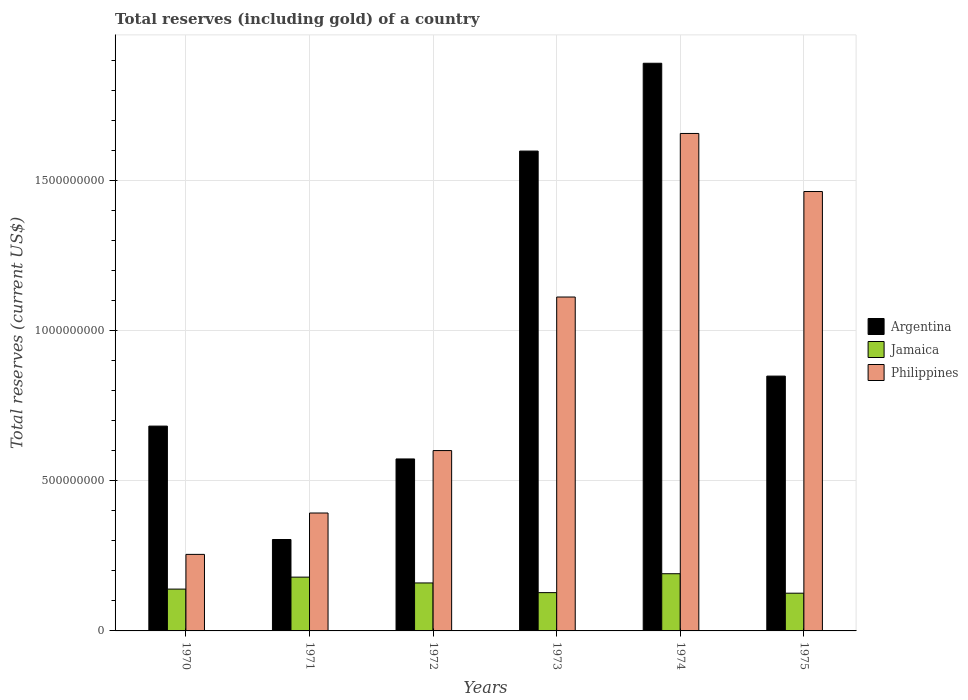Are the number of bars on each tick of the X-axis equal?
Give a very brief answer. Yes. How many bars are there on the 1st tick from the left?
Keep it short and to the point. 3. What is the label of the 6th group of bars from the left?
Your answer should be very brief. 1975. What is the total reserves (including gold) in Philippines in 1970?
Keep it short and to the point. 2.55e+08. Across all years, what is the maximum total reserves (including gold) in Argentina?
Provide a short and direct response. 1.89e+09. Across all years, what is the minimum total reserves (including gold) in Jamaica?
Provide a succinct answer. 1.26e+08. In which year was the total reserves (including gold) in Jamaica maximum?
Give a very brief answer. 1974. In which year was the total reserves (including gold) in Jamaica minimum?
Ensure brevity in your answer.  1975. What is the total total reserves (including gold) in Philippines in the graph?
Ensure brevity in your answer.  5.48e+09. What is the difference between the total reserves (including gold) in Jamaica in 1972 and that in 1974?
Give a very brief answer. -3.07e+07. What is the difference between the total reserves (including gold) in Philippines in 1975 and the total reserves (including gold) in Argentina in 1971?
Provide a succinct answer. 1.16e+09. What is the average total reserves (including gold) in Philippines per year?
Your response must be concise. 9.13e+08. In the year 1974, what is the difference between the total reserves (including gold) in Argentina and total reserves (including gold) in Jamaica?
Offer a terse response. 1.70e+09. In how many years, is the total reserves (including gold) in Philippines greater than 100000000 US$?
Give a very brief answer. 6. What is the ratio of the total reserves (including gold) in Philippines in 1972 to that in 1975?
Make the answer very short. 0.41. Is the difference between the total reserves (including gold) in Argentina in 1972 and 1973 greater than the difference between the total reserves (including gold) in Jamaica in 1972 and 1973?
Provide a short and direct response. No. What is the difference between the highest and the second highest total reserves (including gold) in Philippines?
Give a very brief answer. 1.93e+08. What is the difference between the highest and the lowest total reserves (including gold) in Philippines?
Your answer should be very brief. 1.40e+09. In how many years, is the total reserves (including gold) in Philippines greater than the average total reserves (including gold) in Philippines taken over all years?
Ensure brevity in your answer.  3. Is the sum of the total reserves (including gold) in Philippines in 1972 and 1975 greater than the maximum total reserves (including gold) in Argentina across all years?
Make the answer very short. Yes. What does the 2nd bar from the left in 1970 represents?
Your answer should be compact. Jamaica. What does the 3rd bar from the right in 1970 represents?
Your answer should be compact. Argentina. Is it the case that in every year, the sum of the total reserves (including gold) in Jamaica and total reserves (including gold) in Argentina is greater than the total reserves (including gold) in Philippines?
Provide a succinct answer. No. How many bars are there?
Give a very brief answer. 18. Are all the bars in the graph horizontal?
Give a very brief answer. No. Are the values on the major ticks of Y-axis written in scientific E-notation?
Offer a very short reply. No. Where does the legend appear in the graph?
Keep it short and to the point. Center right. What is the title of the graph?
Give a very brief answer. Total reserves (including gold) of a country. Does "Georgia" appear as one of the legend labels in the graph?
Provide a short and direct response. No. What is the label or title of the Y-axis?
Provide a succinct answer. Total reserves (current US$). What is the Total reserves (current US$) of Argentina in 1970?
Provide a succinct answer. 6.82e+08. What is the Total reserves (current US$) in Jamaica in 1970?
Offer a very short reply. 1.39e+08. What is the Total reserves (current US$) of Philippines in 1970?
Your answer should be compact. 2.55e+08. What is the Total reserves (current US$) of Argentina in 1971?
Your answer should be very brief. 3.04e+08. What is the Total reserves (current US$) of Jamaica in 1971?
Make the answer very short. 1.79e+08. What is the Total reserves (current US$) in Philippines in 1971?
Keep it short and to the point. 3.93e+08. What is the Total reserves (current US$) in Argentina in 1972?
Give a very brief answer. 5.72e+08. What is the Total reserves (current US$) in Jamaica in 1972?
Make the answer very short. 1.60e+08. What is the Total reserves (current US$) of Philippines in 1972?
Provide a succinct answer. 6.00e+08. What is the Total reserves (current US$) in Argentina in 1973?
Provide a succinct answer. 1.60e+09. What is the Total reserves (current US$) in Jamaica in 1973?
Make the answer very short. 1.27e+08. What is the Total reserves (current US$) of Philippines in 1973?
Provide a succinct answer. 1.11e+09. What is the Total reserves (current US$) in Argentina in 1974?
Offer a very short reply. 1.89e+09. What is the Total reserves (current US$) of Jamaica in 1974?
Your response must be concise. 1.90e+08. What is the Total reserves (current US$) of Philippines in 1974?
Ensure brevity in your answer.  1.66e+09. What is the Total reserves (current US$) of Argentina in 1975?
Your response must be concise. 8.48e+08. What is the Total reserves (current US$) in Jamaica in 1975?
Provide a short and direct response. 1.26e+08. What is the Total reserves (current US$) of Philippines in 1975?
Give a very brief answer. 1.46e+09. Across all years, what is the maximum Total reserves (current US$) of Argentina?
Your answer should be very brief. 1.89e+09. Across all years, what is the maximum Total reserves (current US$) of Jamaica?
Make the answer very short. 1.90e+08. Across all years, what is the maximum Total reserves (current US$) in Philippines?
Provide a short and direct response. 1.66e+09. Across all years, what is the minimum Total reserves (current US$) in Argentina?
Offer a terse response. 3.04e+08. Across all years, what is the minimum Total reserves (current US$) of Jamaica?
Your answer should be compact. 1.26e+08. Across all years, what is the minimum Total reserves (current US$) of Philippines?
Your response must be concise. 2.55e+08. What is the total Total reserves (current US$) of Argentina in the graph?
Provide a short and direct response. 5.89e+09. What is the total Total reserves (current US$) in Jamaica in the graph?
Provide a short and direct response. 9.21e+08. What is the total Total reserves (current US$) of Philippines in the graph?
Your response must be concise. 5.48e+09. What is the difference between the Total reserves (current US$) in Argentina in 1970 and that in 1971?
Your answer should be compact. 3.77e+08. What is the difference between the Total reserves (current US$) of Jamaica in 1970 and that in 1971?
Provide a succinct answer. -3.99e+07. What is the difference between the Total reserves (current US$) in Philippines in 1970 and that in 1971?
Your answer should be very brief. -1.38e+08. What is the difference between the Total reserves (current US$) in Argentina in 1970 and that in 1972?
Offer a very short reply. 1.09e+08. What is the difference between the Total reserves (current US$) of Jamaica in 1970 and that in 1972?
Provide a succinct answer. -2.05e+07. What is the difference between the Total reserves (current US$) in Philippines in 1970 and that in 1972?
Offer a terse response. -3.46e+08. What is the difference between the Total reserves (current US$) of Argentina in 1970 and that in 1973?
Your answer should be very brief. -9.15e+08. What is the difference between the Total reserves (current US$) of Jamaica in 1970 and that in 1973?
Make the answer very short. 1.17e+07. What is the difference between the Total reserves (current US$) in Philippines in 1970 and that in 1973?
Offer a terse response. -8.57e+08. What is the difference between the Total reserves (current US$) in Argentina in 1970 and that in 1974?
Provide a succinct answer. -1.21e+09. What is the difference between the Total reserves (current US$) of Jamaica in 1970 and that in 1974?
Ensure brevity in your answer.  -5.12e+07. What is the difference between the Total reserves (current US$) of Philippines in 1970 and that in 1974?
Make the answer very short. -1.40e+09. What is the difference between the Total reserves (current US$) in Argentina in 1970 and that in 1975?
Ensure brevity in your answer.  -1.66e+08. What is the difference between the Total reserves (current US$) of Jamaica in 1970 and that in 1975?
Give a very brief answer. 1.36e+07. What is the difference between the Total reserves (current US$) in Philippines in 1970 and that in 1975?
Offer a very short reply. -1.21e+09. What is the difference between the Total reserves (current US$) of Argentina in 1971 and that in 1972?
Keep it short and to the point. -2.68e+08. What is the difference between the Total reserves (current US$) of Jamaica in 1971 and that in 1972?
Keep it short and to the point. 1.94e+07. What is the difference between the Total reserves (current US$) of Philippines in 1971 and that in 1972?
Give a very brief answer. -2.08e+08. What is the difference between the Total reserves (current US$) of Argentina in 1971 and that in 1973?
Your answer should be very brief. -1.29e+09. What is the difference between the Total reserves (current US$) of Jamaica in 1971 and that in 1973?
Ensure brevity in your answer.  5.16e+07. What is the difference between the Total reserves (current US$) in Philippines in 1971 and that in 1973?
Ensure brevity in your answer.  -7.19e+08. What is the difference between the Total reserves (current US$) in Argentina in 1971 and that in 1974?
Keep it short and to the point. -1.59e+09. What is the difference between the Total reserves (current US$) of Jamaica in 1971 and that in 1974?
Give a very brief answer. -1.13e+07. What is the difference between the Total reserves (current US$) of Philippines in 1971 and that in 1974?
Provide a succinct answer. -1.26e+09. What is the difference between the Total reserves (current US$) of Argentina in 1971 and that in 1975?
Keep it short and to the point. -5.44e+08. What is the difference between the Total reserves (current US$) of Jamaica in 1971 and that in 1975?
Keep it short and to the point. 5.35e+07. What is the difference between the Total reserves (current US$) of Philippines in 1971 and that in 1975?
Keep it short and to the point. -1.07e+09. What is the difference between the Total reserves (current US$) of Argentina in 1972 and that in 1973?
Your answer should be very brief. -1.02e+09. What is the difference between the Total reserves (current US$) of Jamaica in 1972 and that in 1973?
Give a very brief answer. 3.22e+07. What is the difference between the Total reserves (current US$) of Philippines in 1972 and that in 1973?
Your answer should be very brief. -5.11e+08. What is the difference between the Total reserves (current US$) of Argentina in 1972 and that in 1974?
Your answer should be compact. -1.32e+09. What is the difference between the Total reserves (current US$) in Jamaica in 1972 and that in 1974?
Provide a short and direct response. -3.07e+07. What is the difference between the Total reserves (current US$) in Philippines in 1972 and that in 1974?
Your answer should be compact. -1.06e+09. What is the difference between the Total reserves (current US$) in Argentina in 1972 and that in 1975?
Provide a short and direct response. -2.76e+08. What is the difference between the Total reserves (current US$) of Jamaica in 1972 and that in 1975?
Give a very brief answer. 3.41e+07. What is the difference between the Total reserves (current US$) in Philippines in 1972 and that in 1975?
Give a very brief answer. -8.62e+08. What is the difference between the Total reserves (current US$) of Argentina in 1973 and that in 1974?
Your response must be concise. -2.92e+08. What is the difference between the Total reserves (current US$) in Jamaica in 1973 and that in 1974?
Offer a terse response. -6.29e+07. What is the difference between the Total reserves (current US$) of Philippines in 1973 and that in 1974?
Keep it short and to the point. -5.44e+08. What is the difference between the Total reserves (current US$) in Argentina in 1973 and that in 1975?
Your answer should be very brief. 7.49e+08. What is the difference between the Total reserves (current US$) in Jamaica in 1973 and that in 1975?
Make the answer very short. 1.87e+06. What is the difference between the Total reserves (current US$) of Philippines in 1973 and that in 1975?
Provide a short and direct response. -3.51e+08. What is the difference between the Total reserves (current US$) of Argentina in 1974 and that in 1975?
Keep it short and to the point. 1.04e+09. What is the difference between the Total reserves (current US$) in Jamaica in 1974 and that in 1975?
Your response must be concise. 6.48e+07. What is the difference between the Total reserves (current US$) in Philippines in 1974 and that in 1975?
Your answer should be very brief. 1.93e+08. What is the difference between the Total reserves (current US$) of Argentina in 1970 and the Total reserves (current US$) of Jamaica in 1971?
Provide a short and direct response. 5.03e+08. What is the difference between the Total reserves (current US$) of Argentina in 1970 and the Total reserves (current US$) of Philippines in 1971?
Offer a very short reply. 2.89e+08. What is the difference between the Total reserves (current US$) in Jamaica in 1970 and the Total reserves (current US$) in Philippines in 1971?
Keep it short and to the point. -2.53e+08. What is the difference between the Total reserves (current US$) of Argentina in 1970 and the Total reserves (current US$) of Jamaica in 1972?
Ensure brevity in your answer.  5.22e+08. What is the difference between the Total reserves (current US$) of Argentina in 1970 and the Total reserves (current US$) of Philippines in 1972?
Offer a terse response. 8.15e+07. What is the difference between the Total reserves (current US$) in Jamaica in 1970 and the Total reserves (current US$) in Philippines in 1972?
Provide a succinct answer. -4.61e+08. What is the difference between the Total reserves (current US$) of Argentina in 1970 and the Total reserves (current US$) of Jamaica in 1973?
Offer a terse response. 5.54e+08. What is the difference between the Total reserves (current US$) of Argentina in 1970 and the Total reserves (current US$) of Philippines in 1973?
Keep it short and to the point. -4.30e+08. What is the difference between the Total reserves (current US$) of Jamaica in 1970 and the Total reserves (current US$) of Philippines in 1973?
Keep it short and to the point. -9.72e+08. What is the difference between the Total reserves (current US$) in Argentina in 1970 and the Total reserves (current US$) in Jamaica in 1974?
Your answer should be compact. 4.91e+08. What is the difference between the Total reserves (current US$) of Argentina in 1970 and the Total reserves (current US$) of Philippines in 1974?
Your response must be concise. -9.74e+08. What is the difference between the Total reserves (current US$) of Jamaica in 1970 and the Total reserves (current US$) of Philippines in 1974?
Make the answer very short. -1.52e+09. What is the difference between the Total reserves (current US$) of Argentina in 1970 and the Total reserves (current US$) of Jamaica in 1975?
Provide a short and direct response. 5.56e+08. What is the difference between the Total reserves (current US$) in Argentina in 1970 and the Total reserves (current US$) in Philippines in 1975?
Ensure brevity in your answer.  -7.81e+08. What is the difference between the Total reserves (current US$) of Jamaica in 1970 and the Total reserves (current US$) of Philippines in 1975?
Your answer should be very brief. -1.32e+09. What is the difference between the Total reserves (current US$) in Argentina in 1971 and the Total reserves (current US$) in Jamaica in 1972?
Your answer should be compact. 1.45e+08. What is the difference between the Total reserves (current US$) in Argentina in 1971 and the Total reserves (current US$) in Philippines in 1972?
Your response must be concise. -2.96e+08. What is the difference between the Total reserves (current US$) of Jamaica in 1971 and the Total reserves (current US$) of Philippines in 1972?
Your response must be concise. -4.21e+08. What is the difference between the Total reserves (current US$) of Argentina in 1971 and the Total reserves (current US$) of Jamaica in 1973?
Provide a short and direct response. 1.77e+08. What is the difference between the Total reserves (current US$) of Argentina in 1971 and the Total reserves (current US$) of Philippines in 1973?
Provide a succinct answer. -8.07e+08. What is the difference between the Total reserves (current US$) of Jamaica in 1971 and the Total reserves (current US$) of Philippines in 1973?
Offer a terse response. -9.32e+08. What is the difference between the Total reserves (current US$) of Argentina in 1971 and the Total reserves (current US$) of Jamaica in 1974?
Ensure brevity in your answer.  1.14e+08. What is the difference between the Total reserves (current US$) of Argentina in 1971 and the Total reserves (current US$) of Philippines in 1974?
Keep it short and to the point. -1.35e+09. What is the difference between the Total reserves (current US$) of Jamaica in 1971 and the Total reserves (current US$) of Philippines in 1974?
Your answer should be compact. -1.48e+09. What is the difference between the Total reserves (current US$) of Argentina in 1971 and the Total reserves (current US$) of Jamaica in 1975?
Your response must be concise. 1.79e+08. What is the difference between the Total reserves (current US$) in Argentina in 1971 and the Total reserves (current US$) in Philippines in 1975?
Your answer should be very brief. -1.16e+09. What is the difference between the Total reserves (current US$) of Jamaica in 1971 and the Total reserves (current US$) of Philippines in 1975?
Offer a very short reply. -1.28e+09. What is the difference between the Total reserves (current US$) in Argentina in 1972 and the Total reserves (current US$) in Jamaica in 1973?
Offer a very short reply. 4.45e+08. What is the difference between the Total reserves (current US$) of Argentina in 1972 and the Total reserves (current US$) of Philippines in 1973?
Your answer should be very brief. -5.39e+08. What is the difference between the Total reserves (current US$) in Jamaica in 1972 and the Total reserves (current US$) in Philippines in 1973?
Your response must be concise. -9.52e+08. What is the difference between the Total reserves (current US$) in Argentina in 1972 and the Total reserves (current US$) in Jamaica in 1974?
Ensure brevity in your answer.  3.82e+08. What is the difference between the Total reserves (current US$) of Argentina in 1972 and the Total reserves (current US$) of Philippines in 1974?
Keep it short and to the point. -1.08e+09. What is the difference between the Total reserves (current US$) of Jamaica in 1972 and the Total reserves (current US$) of Philippines in 1974?
Offer a very short reply. -1.50e+09. What is the difference between the Total reserves (current US$) in Argentina in 1972 and the Total reserves (current US$) in Jamaica in 1975?
Your answer should be very brief. 4.47e+08. What is the difference between the Total reserves (current US$) of Argentina in 1972 and the Total reserves (current US$) of Philippines in 1975?
Ensure brevity in your answer.  -8.90e+08. What is the difference between the Total reserves (current US$) of Jamaica in 1972 and the Total reserves (current US$) of Philippines in 1975?
Ensure brevity in your answer.  -1.30e+09. What is the difference between the Total reserves (current US$) in Argentina in 1973 and the Total reserves (current US$) in Jamaica in 1974?
Make the answer very short. 1.41e+09. What is the difference between the Total reserves (current US$) in Argentina in 1973 and the Total reserves (current US$) in Philippines in 1974?
Provide a short and direct response. -5.86e+07. What is the difference between the Total reserves (current US$) of Jamaica in 1973 and the Total reserves (current US$) of Philippines in 1974?
Provide a succinct answer. -1.53e+09. What is the difference between the Total reserves (current US$) in Argentina in 1973 and the Total reserves (current US$) in Jamaica in 1975?
Ensure brevity in your answer.  1.47e+09. What is the difference between the Total reserves (current US$) in Argentina in 1973 and the Total reserves (current US$) in Philippines in 1975?
Your response must be concise. 1.35e+08. What is the difference between the Total reserves (current US$) of Jamaica in 1973 and the Total reserves (current US$) of Philippines in 1975?
Your answer should be compact. -1.34e+09. What is the difference between the Total reserves (current US$) of Argentina in 1974 and the Total reserves (current US$) of Jamaica in 1975?
Keep it short and to the point. 1.76e+09. What is the difference between the Total reserves (current US$) of Argentina in 1974 and the Total reserves (current US$) of Philippines in 1975?
Your answer should be compact. 4.27e+08. What is the difference between the Total reserves (current US$) of Jamaica in 1974 and the Total reserves (current US$) of Philippines in 1975?
Your response must be concise. -1.27e+09. What is the average Total reserves (current US$) in Argentina per year?
Offer a terse response. 9.82e+08. What is the average Total reserves (current US$) in Jamaica per year?
Your answer should be very brief. 1.54e+08. What is the average Total reserves (current US$) of Philippines per year?
Provide a succinct answer. 9.13e+08. In the year 1970, what is the difference between the Total reserves (current US$) of Argentina and Total reserves (current US$) of Jamaica?
Offer a very short reply. 5.43e+08. In the year 1970, what is the difference between the Total reserves (current US$) in Argentina and Total reserves (current US$) in Philippines?
Offer a very short reply. 4.27e+08. In the year 1970, what is the difference between the Total reserves (current US$) in Jamaica and Total reserves (current US$) in Philippines?
Make the answer very short. -1.16e+08. In the year 1971, what is the difference between the Total reserves (current US$) in Argentina and Total reserves (current US$) in Jamaica?
Give a very brief answer. 1.25e+08. In the year 1971, what is the difference between the Total reserves (current US$) in Argentina and Total reserves (current US$) in Philippines?
Make the answer very short. -8.82e+07. In the year 1971, what is the difference between the Total reserves (current US$) of Jamaica and Total reserves (current US$) of Philippines?
Your answer should be compact. -2.13e+08. In the year 1972, what is the difference between the Total reserves (current US$) in Argentina and Total reserves (current US$) in Jamaica?
Ensure brevity in your answer.  4.13e+08. In the year 1972, what is the difference between the Total reserves (current US$) in Argentina and Total reserves (current US$) in Philippines?
Give a very brief answer. -2.79e+07. In the year 1972, what is the difference between the Total reserves (current US$) in Jamaica and Total reserves (current US$) in Philippines?
Your answer should be compact. -4.41e+08. In the year 1973, what is the difference between the Total reserves (current US$) in Argentina and Total reserves (current US$) in Jamaica?
Offer a very short reply. 1.47e+09. In the year 1973, what is the difference between the Total reserves (current US$) in Argentina and Total reserves (current US$) in Philippines?
Provide a short and direct response. 4.86e+08. In the year 1973, what is the difference between the Total reserves (current US$) of Jamaica and Total reserves (current US$) of Philippines?
Keep it short and to the point. -9.84e+08. In the year 1974, what is the difference between the Total reserves (current US$) of Argentina and Total reserves (current US$) of Jamaica?
Your answer should be very brief. 1.70e+09. In the year 1974, what is the difference between the Total reserves (current US$) of Argentina and Total reserves (current US$) of Philippines?
Your response must be concise. 2.34e+08. In the year 1974, what is the difference between the Total reserves (current US$) of Jamaica and Total reserves (current US$) of Philippines?
Your response must be concise. -1.47e+09. In the year 1975, what is the difference between the Total reserves (current US$) in Argentina and Total reserves (current US$) in Jamaica?
Offer a terse response. 7.23e+08. In the year 1975, what is the difference between the Total reserves (current US$) in Argentina and Total reserves (current US$) in Philippines?
Your answer should be compact. -6.14e+08. In the year 1975, what is the difference between the Total reserves (current US$) in Jamaica and Total reserves (current US$) in Philippines?
Provide a succinct answer. -1.34e+09. What is the ratio of the Total reserves (current US$) in Argentina in 1970 to that in 1971?
Your response must be concise. 2.24. What is the ratio of the Total reserves (current US$) of Jamaica in 1970 to that in 1971?
Offer a very short reply. 0.78. What is the ratio of the Total reserves (current US$) in Philippines in 1970 to that in 1971?
Provide a short and direct response. 0.65. What is the ratio of the Total reserves (current US$) in Argentina in 1970 to that in 1972?
Provide a short and direct response. 1.19. What is the ratio of the Total reserves (current US$) of Jamaica in 1970 to that in 1972?
Provide a succinct answer. 0.87. What is the ratio of the Total reserves (current US$) in Philippines in 1970 to that in 1972?
Give a very brief answer. 0.42. What is the ratio of the Total reserves (current US$) in Argentina in 1970 to that in 1973?
Your answer should be compact. 0.43. What is the ratio of the Total reserves (current US$) in Jamaica in 1970 to that in 1973?
Give a very brief answer. 1.09. What is the ratio of the Total reserves (current US$) in Philippines in 1970 to that in 1973?
Keep it short and to the point. 0.23. What is the ratio of the Total reserves (current US$) of Argentina in 1970 to that in 1974?
Give a very brief answer. 0.36. What is the ratio of the Total reserves (current US$) in Jamaica in 1970 to that in 1974?
Offer a terse response. 0.73. What is the ratio of the Total reserves (current US$) in Philippines in 1970 to that in 1974?
Ensure brevity in your answer.  0.15. What is the ratio of the Total reserves (current US$) of Argentina in 1970 to that in 1975?
Keep it short and to the point. 0.8. What is the ratio of the Total reserves (current US$) in Jamaica in 1970 to that in 1975?
Ensure brevity in your answer.  1.11. What is the ratio of the Total reserves (current US$) of Philippines in 1970 to that in 1975?
Your answer should be compact. 0.17. What is the ratio of the Total reserves (current US$) in Argentina in 1971 to that in 1972?
Offer a terse response. 0.53. What is the ratio of the Total reserves (current US$) in Jamaica in 1971 to that in 1972?
Make the answer very short. 1.12. What is the ratio of the Total reserves (current US$) of Philippines in 1971 to that in 1972?
Provide a short and direct response. 0.65. What is the ratio of the Total reserves (current US$) of Argentina in 1971 to that in 1973?
Provide a short and direct response. 0.19. What is the ratio of the Total reserves (current US$) in Jamaica in 1971 to that in 1973?
Make the answer very short. 1.4. What is the ratio of the Total reserves (current US$) in Philippines in 1971 to that in 1973?
Ensure brevity in your answer.  0.35. What is the ratio of the Total reserves (current US$) in Argentina in 1971 to that in 1974?
Ensure brevity in your answer.  0.16. What is the ratio of the Total reserves (current US$) in Jamaica in 1971 to that in 1974?
Ensure brevity in your answer.  0.94. What is the ratio of the Total reserves (current US$) of Philippines in 1971 to that in 1974?
Your answer should be compact. 0.24. What is the ratio of the Total reserves (current US$) in Argentina in 1971 to that in 1975?
Provide a succinct answer. 0.36. What is the ratio of the Total reserves (current US$) of Jamaica in 1971 to that in 1975?
Provide a succinct answer. 1.43. What is the ratio of the Total reserves (current US$) of Philippines in 1971 to that in 1975?
Offer a very short reply. 0.27. What is the ratio of the Total reserves (current US$) of Argentina in 1972 to that in 1973?
Your answer should be very brief. 0.36. What is the ratio of the Total reserves (current US$) of Jamaica in 1972 to that in 1973?
Your answer should be very brief. 1.25. What is the ratio of the Total reserves (current US$) in Philippines in 1972 to that in 1973?
Keep it short and to the point. 0.54. What is the ratio of the Total reserves (current US$) of Argentina in 1972 to that in 1974?
Keep it short and to the point. 0.3. What is the ratio of the Total reserves (current US$) in Jamaica in 1972 to that in 1974?
Offer a terse response. 0.84. What is the ratio of the Total reserves (current US$) in Philippines in 1972 to that in 1974?
Give a very brief answer. 0.36. What is the ratio of the Total reserves (current US$) of Argentina in 1972 to that in 1975?
Give a very brief answer. 0.67. What is the ratio of the Total reserves (current US$) of Jamaica in 1972 to that in 1975?
Make the answer very short. 1.27. What is the ratio of the Total reserves (current US$) of Philippines in 1972 to that in 1975?
Make the answer very short. 0.41. What is the ratio of the Total reserves (current US$) in Argentina in 1973 to that in 1974?
Keep it short and to the point. 0.85. What is the ratio of the Total reserves (current US$) in Jamaica in 1973 to that in 1974?
Keep it short and to the point. 0.67. What is the ratio of the Total reserves (current US$) of Philippines in 1973 to that in 1974?
Ensure brevity in your answer.  0.67. What is the ratio of the Total reserves (current US$) of Argentina in 1973 to that in 1975?
Make the answer very short. 1.88. What is the ratio of the Total reserves (current US$) in Jamaica in 1973 to that in 1975?
Give a very brief answer. 1.01. What is the ratio of the Total reserves (current US$) in Philippines in 1973 to that in 1975?
Your response must be concise. 0.76. What is the ratio of the Total reserves (current US$) of Argentina in 1974 to that in 1975?
Your response must be concise. 2.23. What is the ratio of the Total reserves (current US$) of Jamaica in 1974 to that in 1975?
Provide a succinct answer. 1.52. What is the ratio of the Total reserves (current US$) of Philippines in 1974 to that in 1975?
Your answer should be compact. 1.13. What is the difference between the highest and the second highest Total reserves (current US$) in Argentina?
Provide a short and direct response. 2.92e+08. What is the difference between the highest and the second highest Total reserves (current US$) in Jamaica?
Ensure brevity in your answer.  1.13e+07. What is the difference between the highest and the second highest Total reserves (current US$) of Philippines?
Offer a very short reply. 1.93e+08. What is the difference between the highest and the lowest Total reserves (current US$) in Argentina?
Make the answer very short. 1.59e+09. What is the difference between the highest and the lowest Total reserves (current US$) of Jamaica?
Provide a succinct answer. 6.48e+07. What is the difference between the highest and the lowest Total reserves (current US$) of Philippines?
Provide a short and direct response. 1.40e+09. 